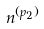Convert formula to latex. <formula><loc_0><loc_0><loc_500><loc_500>n ^ { ( p _ { 2 } ) }</formula> 